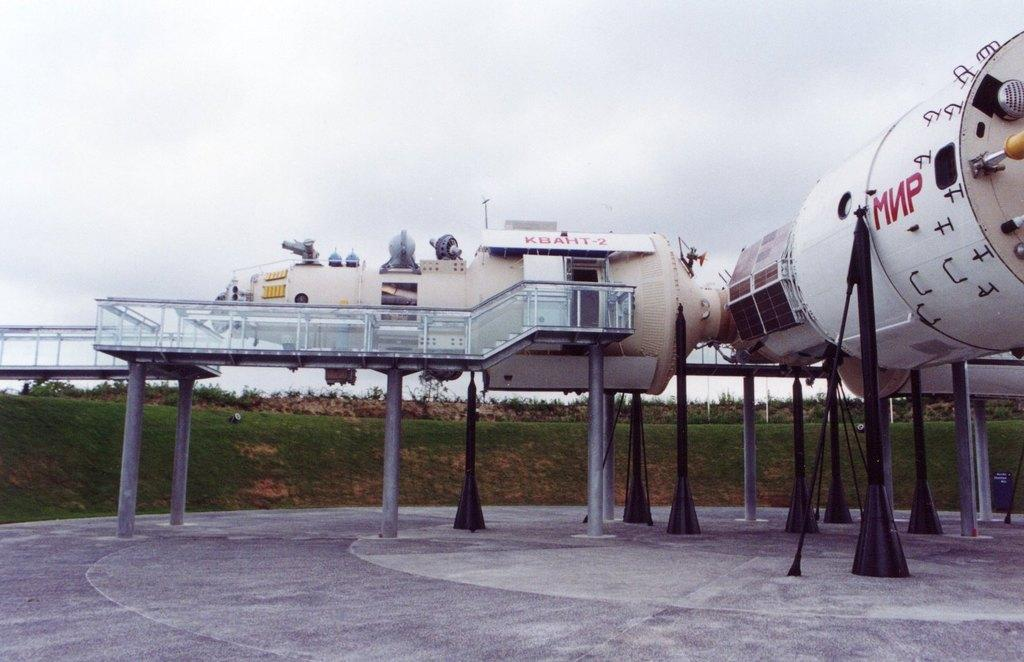What is the main subject of the image? The main subject of the image is a space station. What structures are present near the space station? There are poles and a glass railing visible in the image. What is located at the bottom of the image? There is a platform at the bottom of the image. What can be seen in the background of the image? The background of the image includes grass, a few plants, and the sky. What type of brick is used to construct the smoke in the image? There is no smoke or brick present in the image. How does the air interact with the plants in the background of the image? The image does not show the interaction between air and plants; it only depicts the plants in the background. 